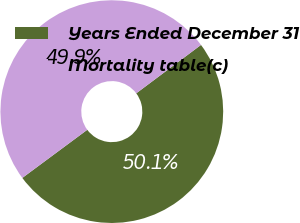Convert chart to OTSL. <chart><loc_0><loc_0><loc_500><loc_500><pie_chart><fcel>Years Ended December 31<fcel>Mortality table(c)<nl><fcel>50.07%<fcel>49.93%<nl></chart> 